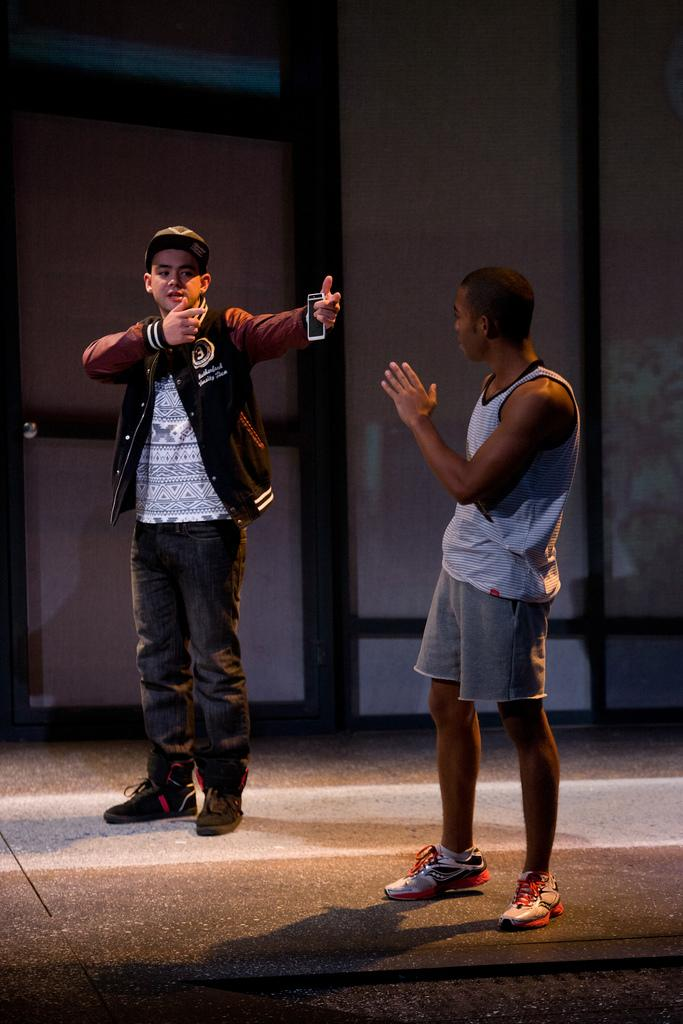How many people are in the image? There are two men standing in the image. What is one of the men holding? One of the men is holding a mobile phone. What feature can be seen on the door in the image? There is a door handle on the door in the image. What type of structure is visible in the image? There is a wall in the image. What vertical object can be seen in the image? There appears to be a pole in the image. What type of toy is the frog playing with in the image? There is no frog or toy present in the image. What is the reason for the men standing in the image? The image does not provide any information about the reason for the men standing; we can only describe what is visible in the image. 